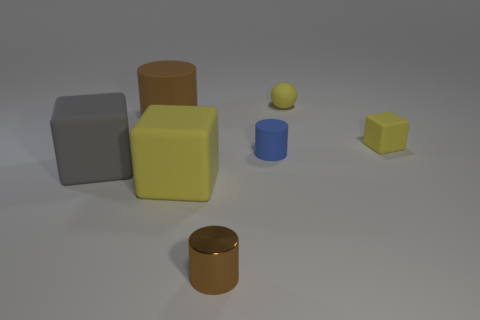The cube that is both left of the tiny brown metallic cylinder and behind the large yellow rubber object is made of what material?
Offer a very short reply. Rubber. Is there a sphere that has the same size as the brown metal cylinder?
Offer a terse response. Yes. How many big brown cubes are there?
Give a very brief answer. 0. What number of large yellow cubes are behind the large brown rubber cylinder?
Make the answer very short. 0. Is the material of the small sphere the same as the large brown object?
Offer a terse response. Yes. How many rubber things are in front of the big brown object and to the left of the small yellow block?
Your response must be concise. 3. How many other objects are the same color as the tiny rubber cube?
Keep it short and to the point. 2. How many blue objects are either matte things or tiny matte cylinders?
Provide a succinct answer. 1. How big is the metallic cylinder?
Keep it short and to the point. Small. What number of matte objects are large cylinders or small yellow blocks?
Offer a terse response. 2. 